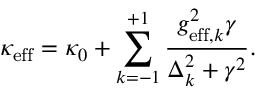Convert formula to latex. <formula><loc_0><loc_0><loc_500><loc_500>\kappa _ { e f f } = \kappa _ { 0 } + \sum _ { k = - 1 } ^ { + 1 } \frac { g _ { e f f , k } ^ { 2 } \gamma } { \Delta _ { k } ^ { 2 } + \gamma ^ { 2 } } .</formula> 